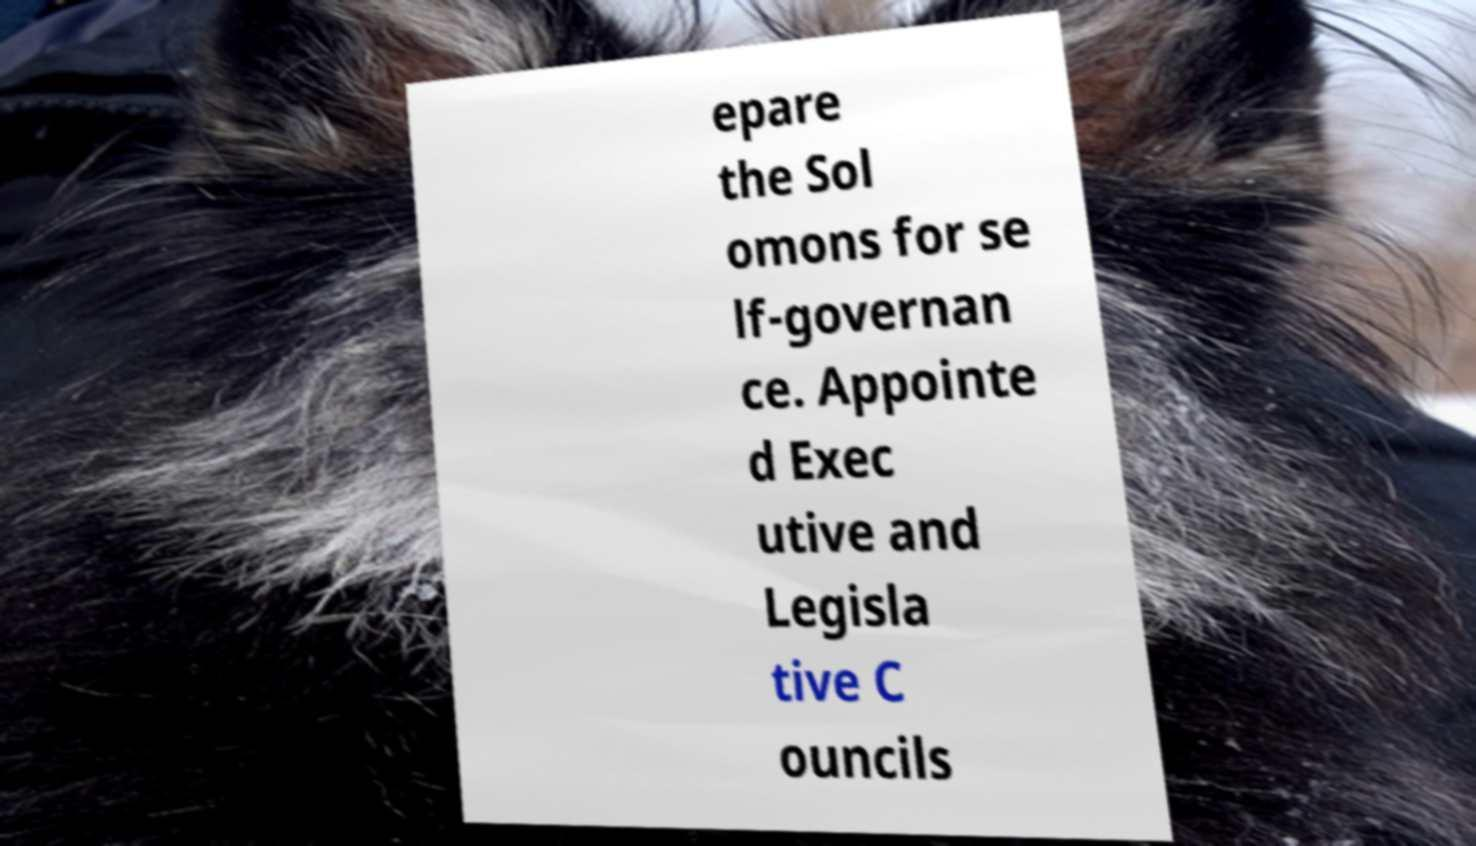I need the written content from this picture converted into text. Can you do that? epare the Sol omons for se lf-governan ce. Appointe d Exec utive and Legisla tive C ouncils 